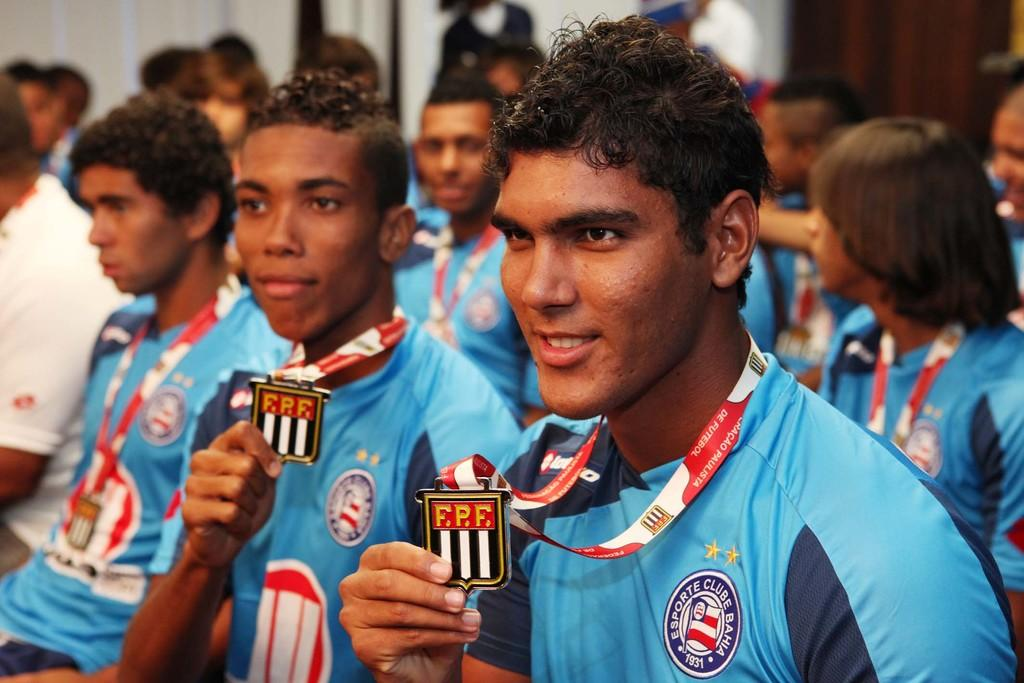Who or what is present in the image? There are people in the image. What are the people wearing? The people are wearing tags. Can you describe the background of the image? The background of the image is blurry. What type of cover is on the squirrel in the image? There is no squirrel present in the image, and therefore no cover on a squirrel. 